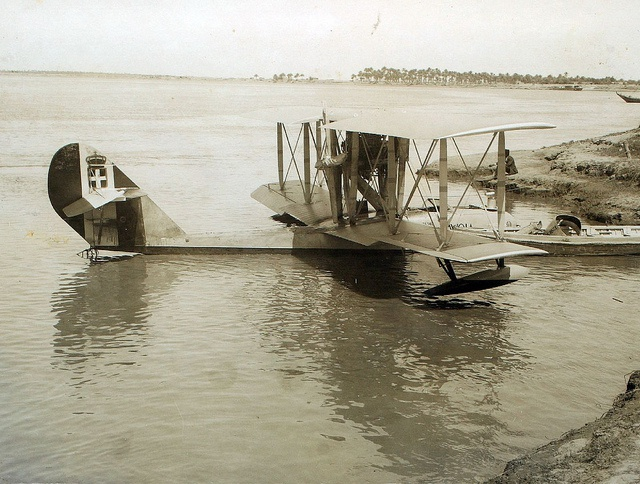Describe the objects in this image and their specific colors. I can see airplane in white, lightgray, black, and gray tones, boat in white, darkgray, gray, and black tones, and people in white, black, darkgreen, gray, and darkgray tones in this image. 